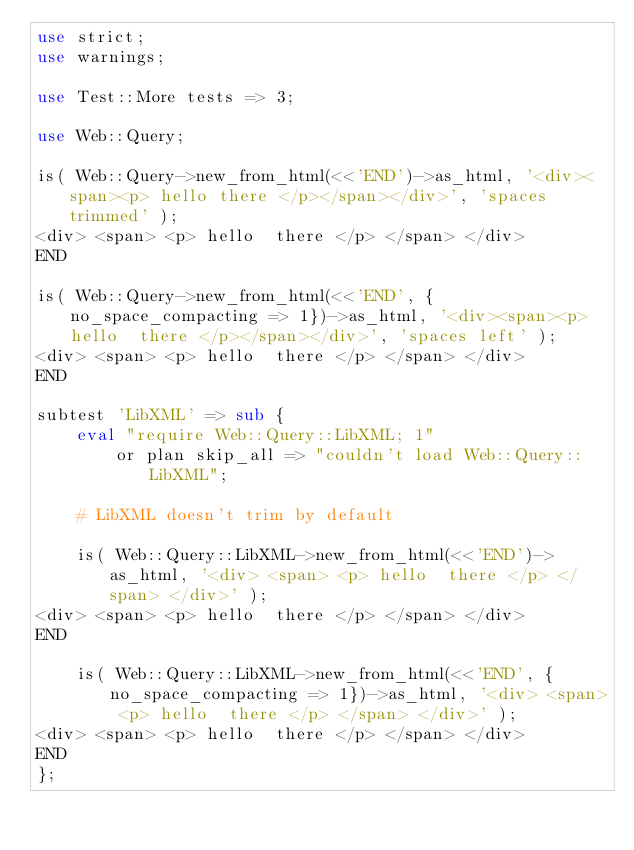<code> <loc_0><loc_0><loc_500><loc_500><_Perl_>use strict;
use warnings;

use Test::More tests => 3;

use Web::Query;

is( Web::Query->new_from_html(<<'END')->as_html, '<div><span><p> hello there </p></span></div>', 'spaces trimmed' );
<div> <span> <p> hello  there </p> </span> </div>
END

is( Web::Query->new_from_html(<<'END', {no_space_compacting => 1})->as_html, '<div><span><p> hello  there </p></span></div>', 'spaces left' );
<div> <span> <p> hello  there </p> </span> </div>
END

subtest 'LibXML' => sub {
    eval "require Web::Query::LibXML; 1" 
        or plan skip_all => "couldn't load Web::Query::LibXML";

    # LibXML doesn't trim by default

    is( Web::Query::LibXML->new_from_html(<<'END')->as_html, '<div> <span> <p> hello  there </p> </span> </div>' );
<div> <span> <p> hello  there </p> </span> </div>
END

    is( Web::Query::LibXML->new_from_html(<<'END', {no_space_compacting => 1})->as_html, '<div> <span> <p> hello  there </p> </span> </div>' );
<div> <span> <p> hello  there </p> </span> </div>
END
};


</code> 